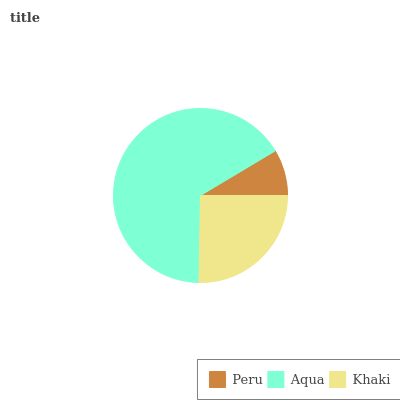Is Peru the minimum?
Answer yes or no. Yes. Is Aqua the maximum?
Answer yes or no. Yes. Is Khaki the minimum?
Answer yes or no. No. Is Khaki the maximum?
Answer yes or no. No. Is Aqua greater than Khaki?
Answer yes or no. Yes. Is Khaki less than Aqua?
Answer yes or no. Yes. Is Khaki greater than Aqua?
Answer yes or no. No. Is Aqua less than Khaki?
Answer yes or no. No. Is Khaki the high median?
Answer yes or no. Yes. Is Khaki the low median?
Answer yes or no. Yes. Is Peru the high median?
Answer yes or no. No. Is Aqua the low median?
Answer yes or no. No. 